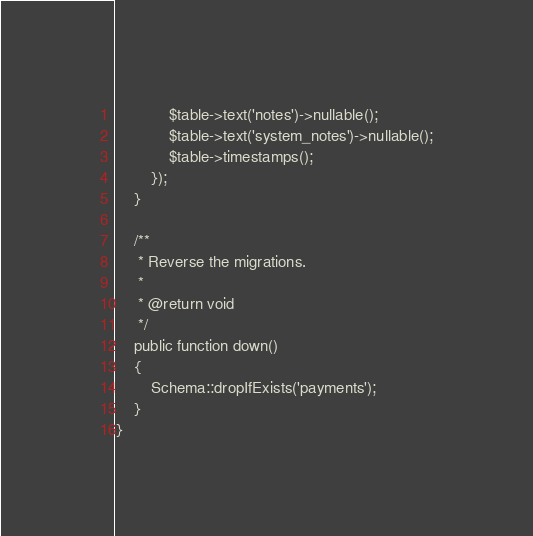<code> <loc_0><loc_0><loc_500><loc_500><_PHP_>            $table->text('notes')->nullable();
            $table->text('system_notes')->nullable();
            $table->timestamps();
        });
    }

    /**
     * Reverse the migrations.
     *
     * @return void
     */
    public function down()
    {
        Schema::dropIfExists('payments');
    }
}
</code> 